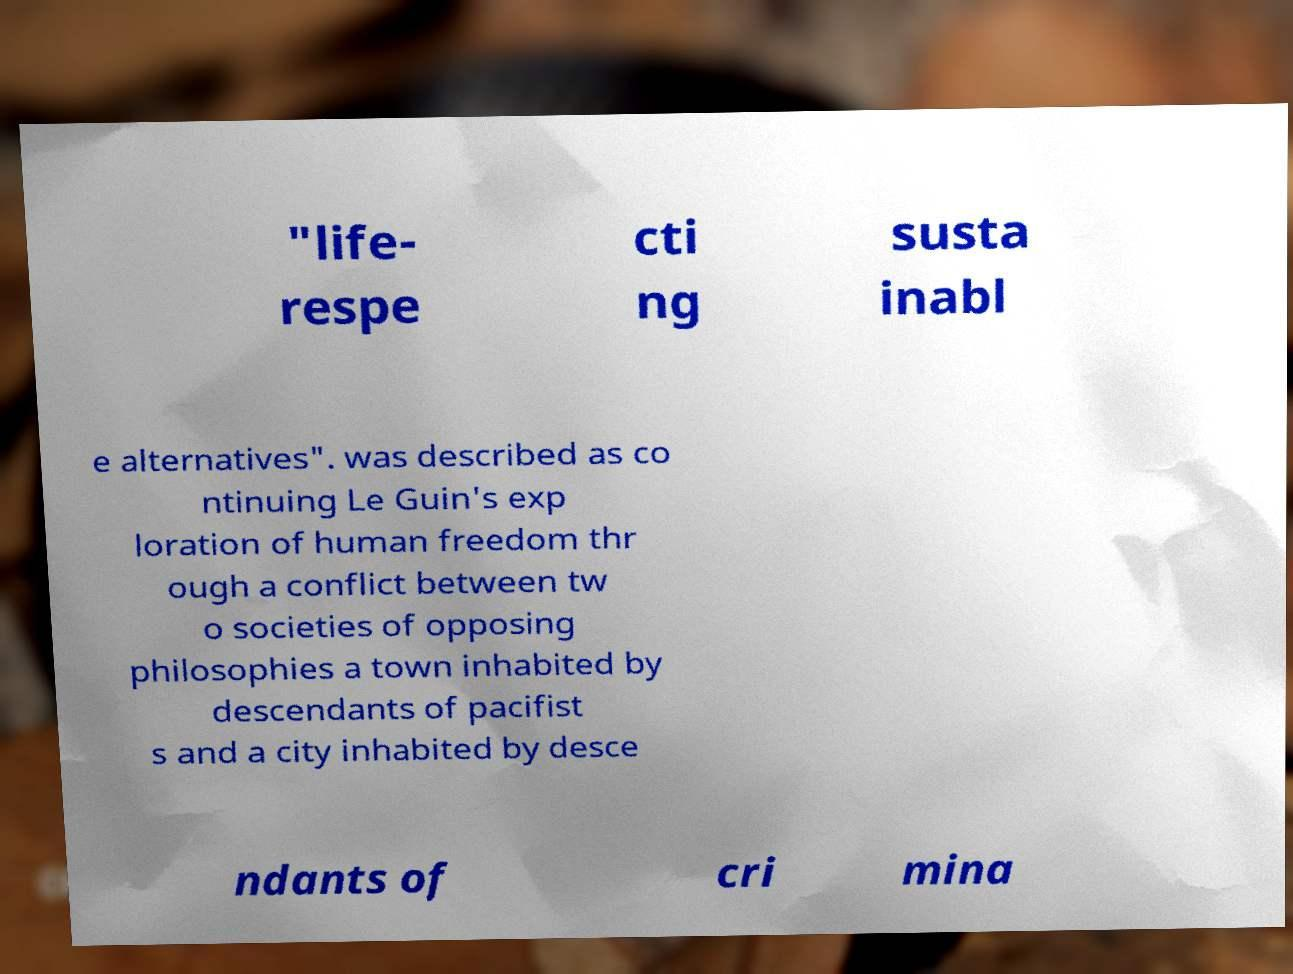Could you extract and type out the text from this image? "life- respe cti ng susta inabl e alternatives". was described as co ntinuing Le Guin's exp loration of human freedom thr ough a conflict between tw o societies of opposing philosophies a town inhabited by descendants of pacifist s and a city inhabited by desce ndants of cri mina 